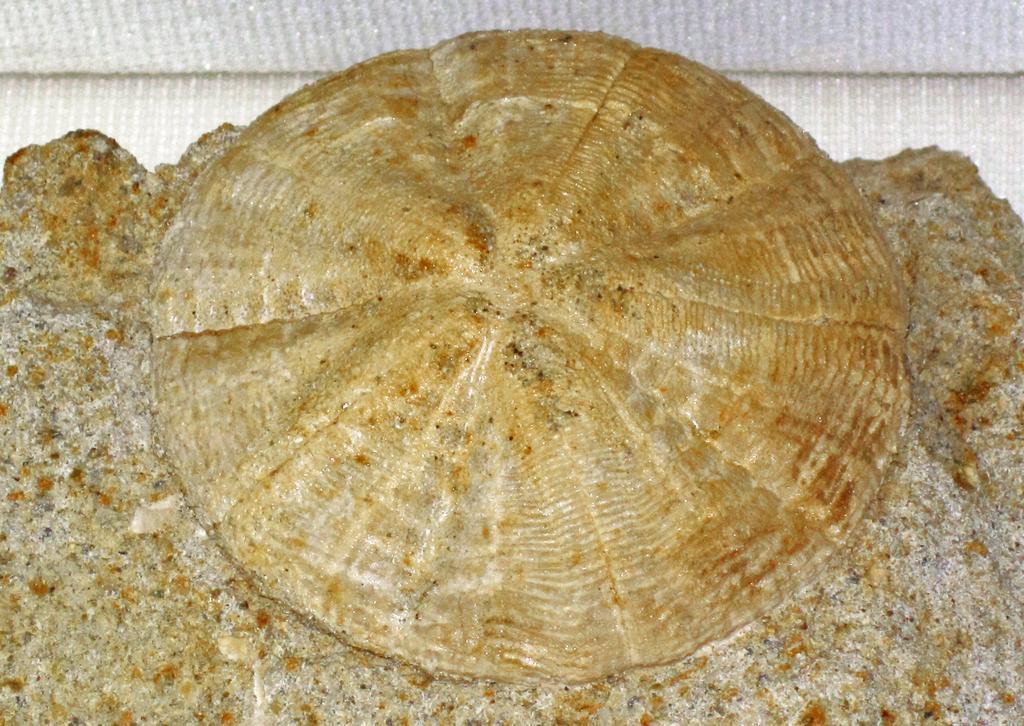Could you give a brief overview of what you see in this image? In this image there is an object. It seems to be a shell. 